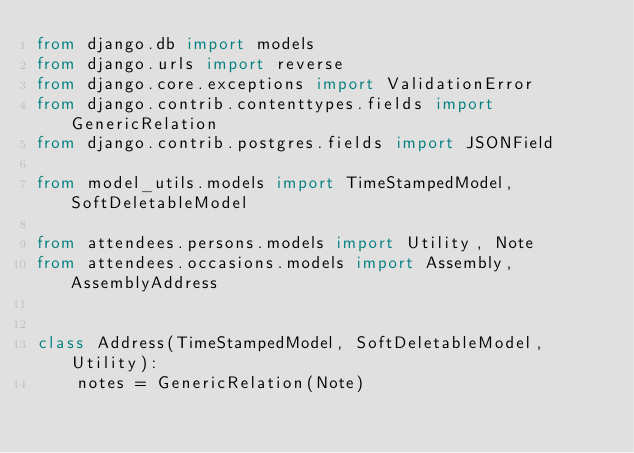Convert code to text. <code><loc_0><loc_0><loc_500><loc_500><_Python_>from django.db import models
from django.urls import reverse
from django.core.exceptions import ValidationError
from django.contrib.contenttypes.fields import GenericRelation
from django.contrib.postgres.fields import JSONField

from model_utils.models import TimeStampedModel, SoftDeletableModel

from attendees.persons.models import Utility, Note
from attendees.occasions.models import Assembly, AssemblyAddress


class Address(TimeStampedModel, SoftDeletableModel, Utility):
    notes = GenericRelation(Note)</code> 